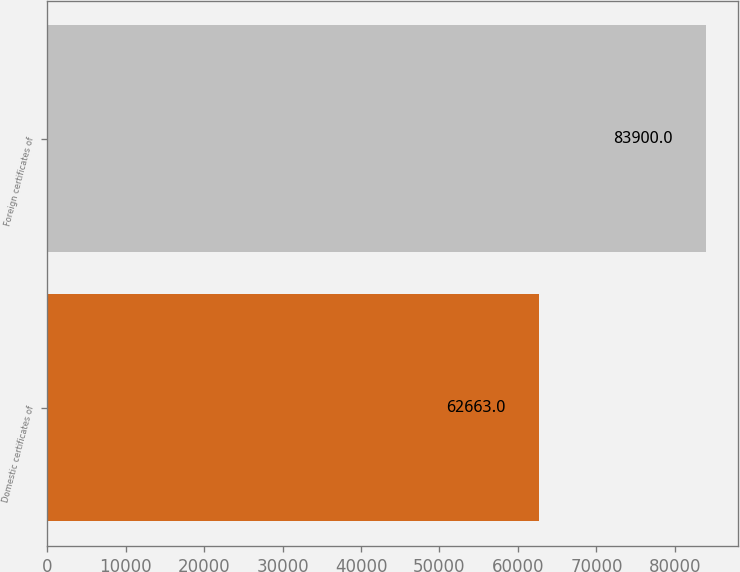Convert chart. <chart><loc_0><loc_0><loc_500><loc_500><bar_chart><fcel>Domestic certificates of<fcel>Foreign certificates of<nl><fcel>62663<fcel>83900<nl></chart> 